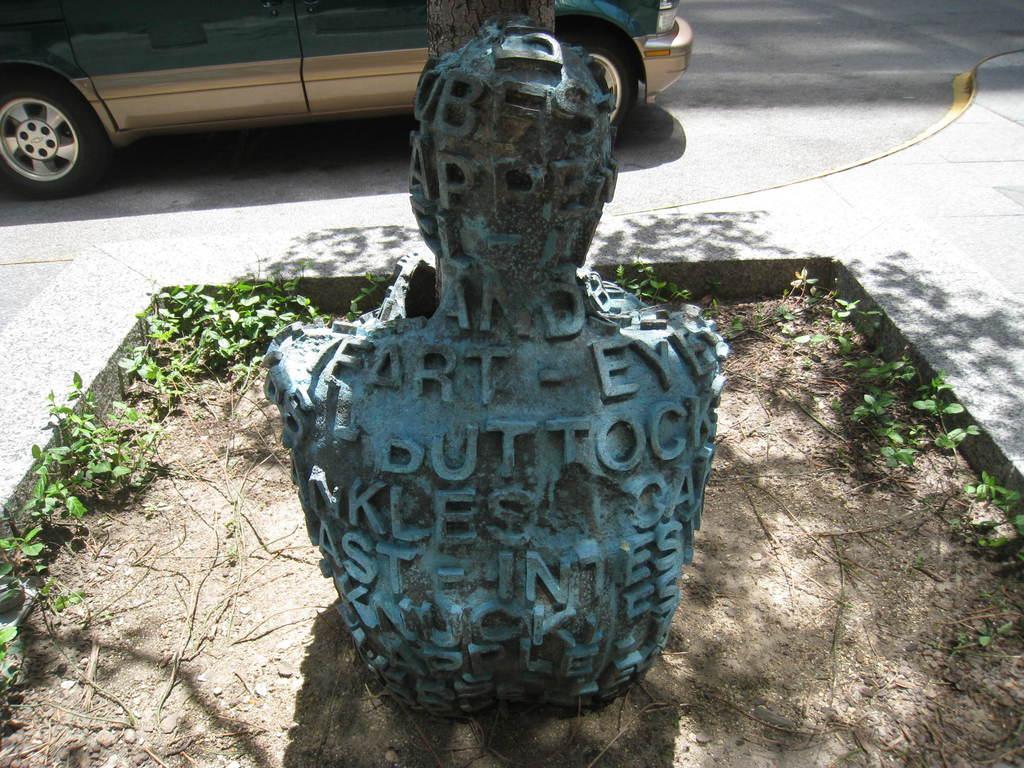Can you describe this image briefly? In this picture there is a statue and there is text on the statue and there are plants. At the back there is a tree and there is a vehicle on the road and there is a shadow of the tree on the footpath. 